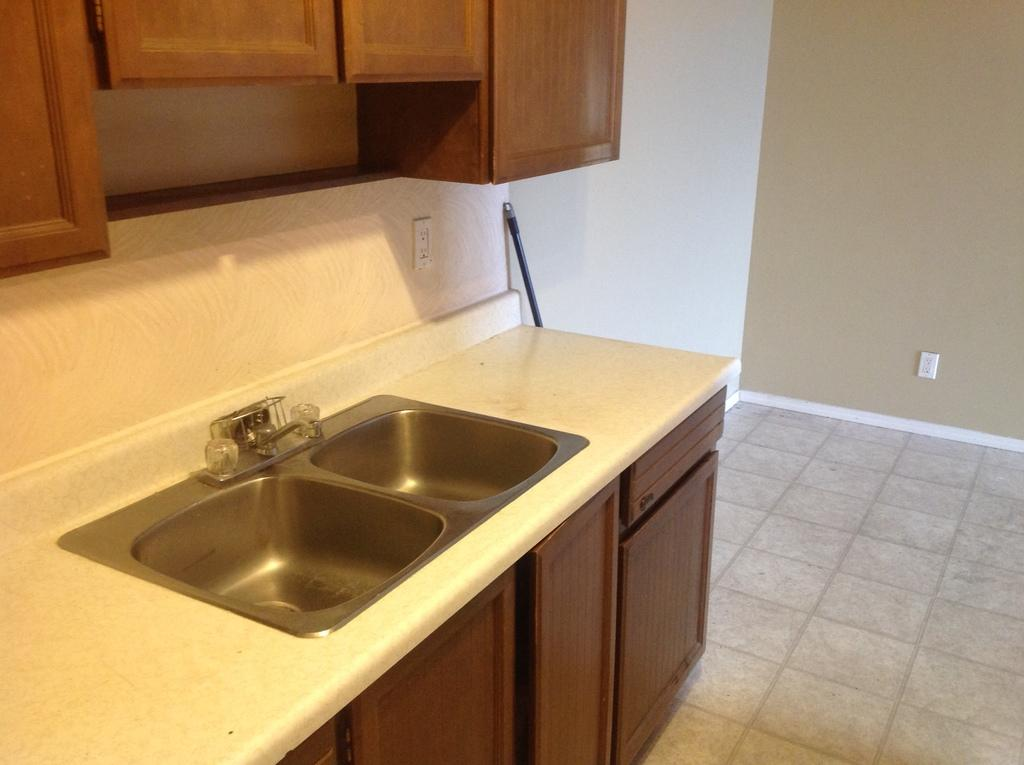What type of fixtures can be seen in the image? There are sinks and a tap visible in the image. What is the surface on which the sinks and tap are placed? The ground is visible in the image. What is attached to the wall in the image? There is a wall with objects, including cupboards, in the image. What is the color of one of the objects in the image? There is a black colored object in the image. Can you see a monkey cracking a nut in the middle of the image? There is no monkey or nut present in the image; it features sinks, a tap, and other objects related to a room or space. 